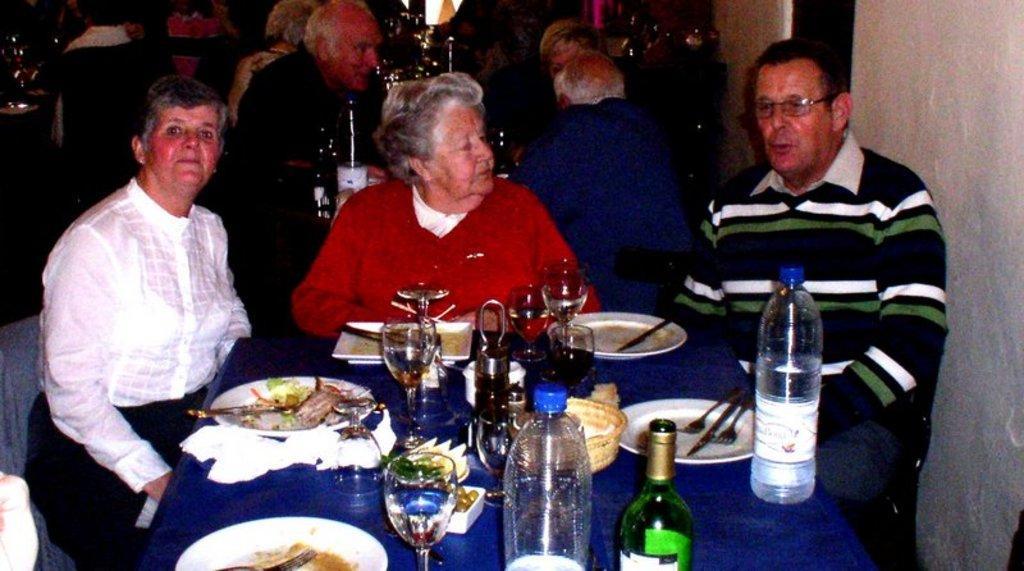How would you summarize this image in a sentence or two? In this picture we can see one man and two women sitting on chair and in front of them there is table and on table we can see bottle, glass, plate with some food in it, fork, knife and in background we can see some more persons. 